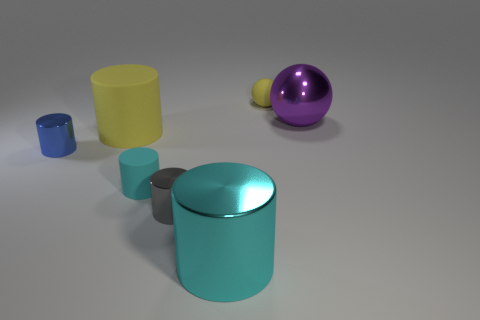Subtract all tiny matte cylinders. How many cylinders are left? 4 Subtract all gray cylinders. How many cylinders are left? 4 Subtract all green cylinders. Subtract all purple blocks. How many cylinders are left? 5 Add 3 big metallic balls. How many objects exist? 10 Subtract all cylinders. How many objects are left? 2 Subtract 1 blue cylinders. How many objects are left? 6 Subtract all gray shiny objects. Subtract all big green cylinders. How many objects are left? 6 Add 1 small blue objects. How many small blue objects are left? 2 Add 5 tiny blue objects. How many tiny blue objects exist? 6 